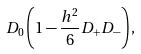Convert formula to latex. <formula><loc_0><loc_0><loc_500><loc_500>D _ { 0 } \left ( 1 - \frac { h ^ { 2 } } { 6 } D _ { + } D _ { - } \right ) ,</formula> 